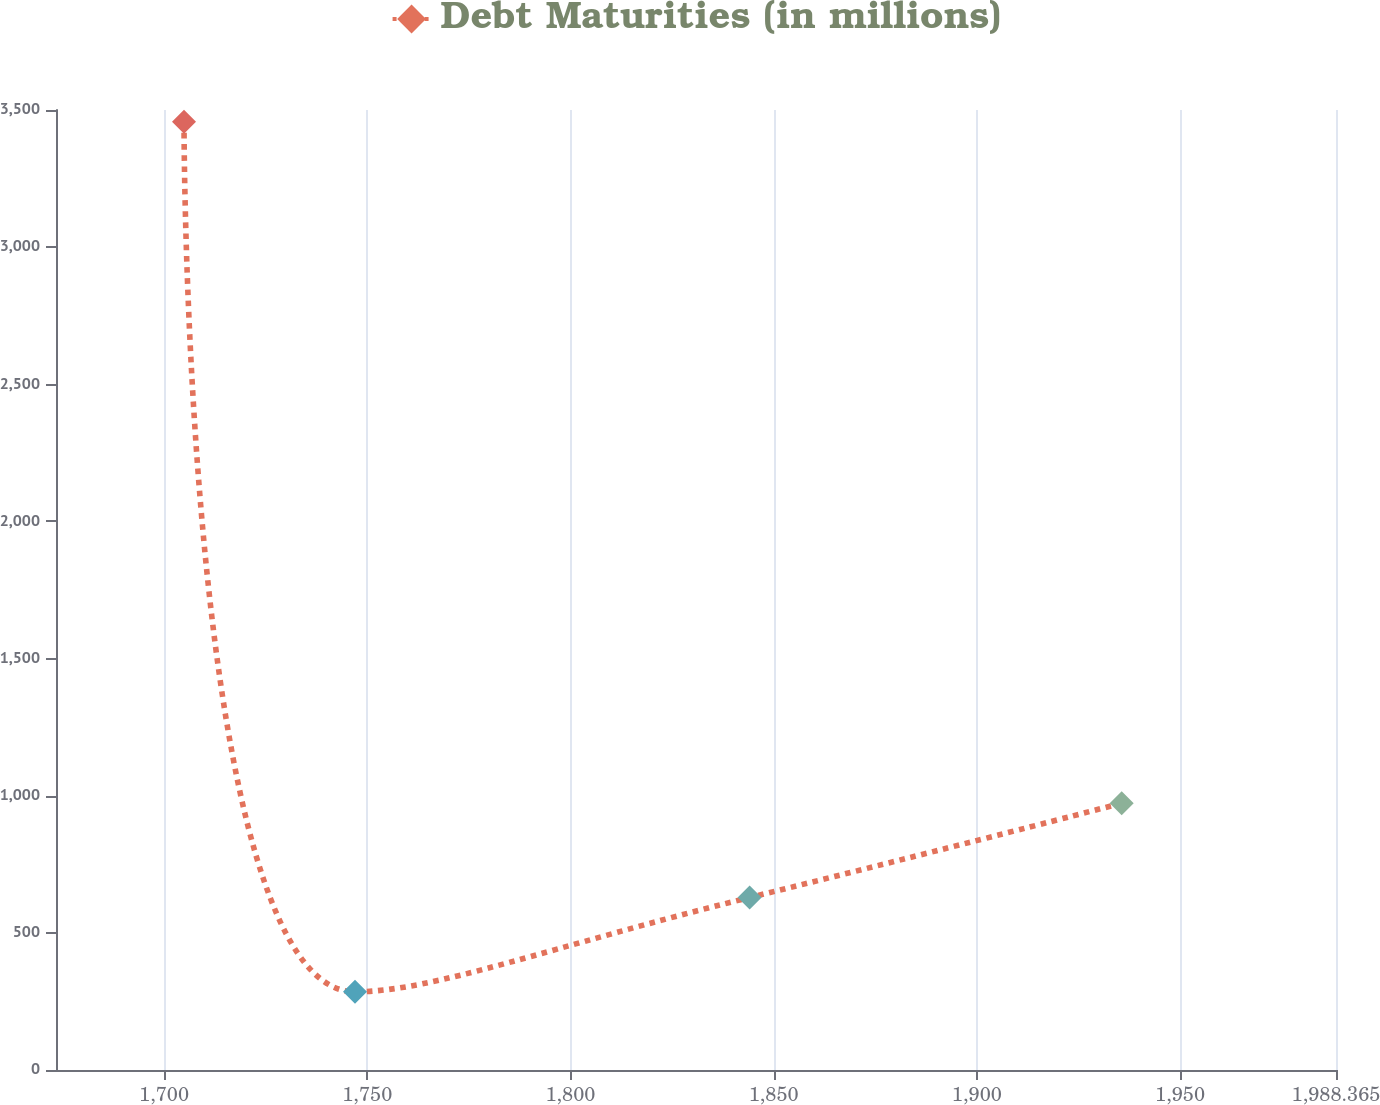Convert chart. <chart><loc_0><loc_0><loc_500><loc_500><line_chart><ecel><fcel>Debt Maturities (in millions)<nl><fcel>1704.91<fcel>3457.24<nl><fcel>1746.98<fcel>285.07<nl><fcel>1844.08<fcel>628.8<nl><fcel>1935.63<fcel>972.52<nl><fcel>2019.86<fcel>3800.96<nl></chart> 